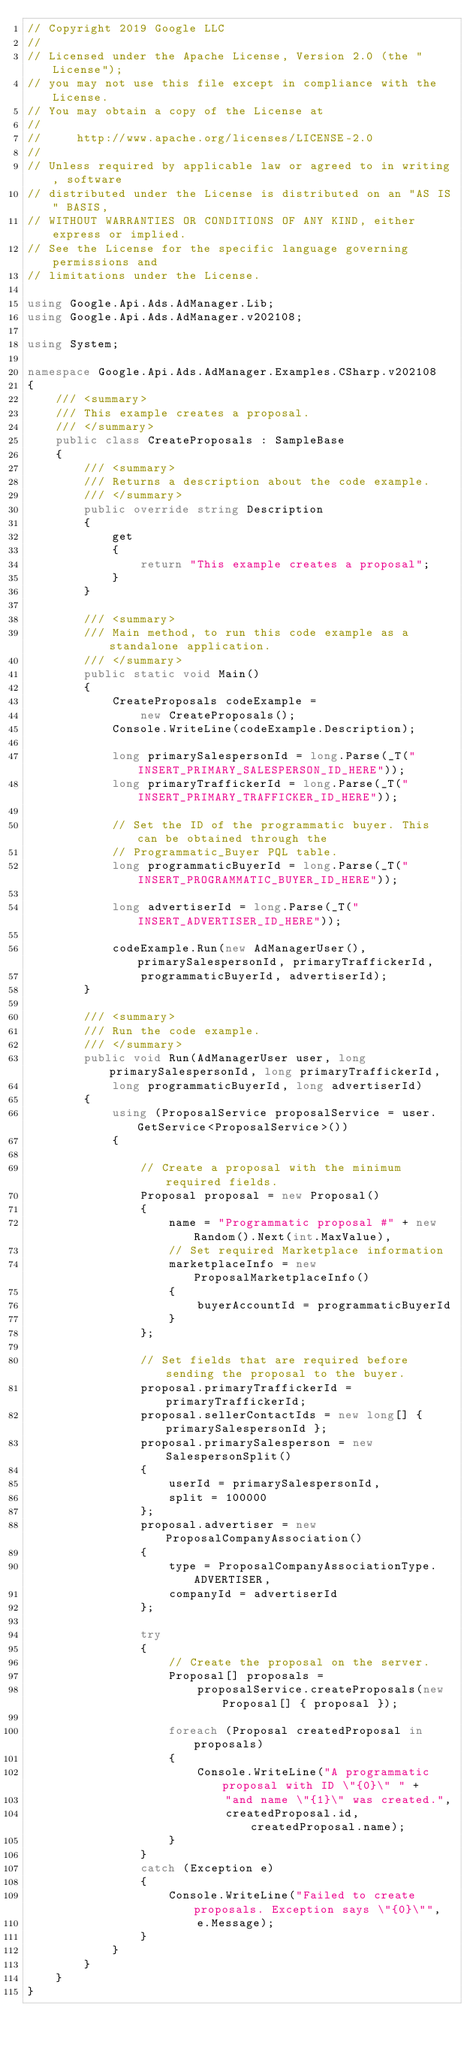Convert code to text. <code><loc_0><loc_0><loc_500><loc_500><_C#_>// Copyright 2019 Google LLC
//
// Licensed under the Apache License, Version 2.0 (the "License");
// you may not use this file except in compliance with the License.
// You may obtain a copy of the License at
//
//     http://www.apache.org/licenses/LICENSE-2.0
//
// Unless required by applicable law or agreed to in writing, software
// distributed under the License is distributed on an "AS IS" BASIS,
// WITHOUT WARRANTIES OR CONDITIONS OF ANY KIND, either express or implied.
// See the License for the specific language governing permissions and
// limitations under the License.

using Google.Api.Ads.AdManager.Lib;
using Google.Api.Ads.AdManager.v202108;

using System;

namespace Google.Api.Ads.AdManager.Examples.CSharp.v202108
{
    /// <summary>
    /// This example creates a proposal.
    /// </summary>
    public class CreateProposals : SampleBase
    {
        /// <summary>
        /// Returns a description about the code example.
        /// </summary>
        public override string Description
        {
            get
            {
                return "This example creates a proposal";
            }
        }

        /// <summary>
        /// Main method, to run this code example as a standalone application.
        /// </summary>
        public static void Main()
        {
            CreateProposals codeExample =
                new CreateProposals();
            Console.WriteLine(codeExample.Description);

            long primarySalespersonId = long.Parse(_T("INSERT_PRIMARY_SALESPERSON_ID_HERE"));
            long primaryTraffickerId = long.Parse(_T("INSERT_PRIMARY_TRAFFICKER_ID_HERE"));

            // Set the ID of the programmatic buyer. This can be obtained through the
            // Programmatic_Buyer PQL table.
            long programmaticBuyerId = long.Parse(_T("INSERT_PROGRAMMATIC_BUYER_ID_HERE"));

            long advertiserId = long.Parse(_T("INSERT_ADVERTISER_ID_HERE"));

            codeExample.Run(new AdManagerUser(), primarySalespersonId, primaryTraffickerId,
                programmaticBuyerId, advertiserId);
        }

        /// <summary>
        /// Run the code example.
        /// </summary>
        public void Run(AdManagerUser user, long primarySalespersonId, long primaryTraffickerId,
            long programmaticBuyerId, long advertiserId)
        {
            using (ProposalService proposalService = user.GetService<ProposalService>())
            {

                // Create a proposal with the minimum required fields.
                Proposal proposal = new Proposal()
                {
                    name = "Programmatic proposal #" + new Random().Next(int.MaxValue),
                    // Set required Marketplace information
                    marketplaceInfo = new ProposalMarketplaceInfo()
                    {
                        buyerAccountId = programmaticBuyerId
                    }
                };

                // Set fields that are required before sending the proposal to the buyer.
                proposal.primaryTraffickerId = primaryTraffickerId;
                proposal.sellerContactIds = new long[] { primarySalespersonId };
                proposal.primarySalesperson = new SalespersonSplit()
                {
                    userId = primarySalespersonId,
                    split = 100000
                };
                proposal.advertiser = new ProposalCompanyAssociation()
                {
                    type = ProposalCompanyAssociationType.ADVERTISER,
                    companyId = advertiserId
                };

                try
                {
                    // Create the proposal on the server.
                    Proposal[] proposals =
                        proposalService.createProposals(new Proposal[] { proposal });

                    foreach (Proposal createdProposal in proposals)
                    {
                        Console.WriteLine("A programmatic proposal with ID \"{0}\" " +
                            "and name \"{1}\" was created.",
                            createdProposal.id, createdProposal.name);
                    }
                }
                catch (Exception e)
                {
                    Console.WriteLine("Failed to create proposals. Exception says \"{0}\"",
                        e.Message);
                }
            }
        }
    }
}
</code> 